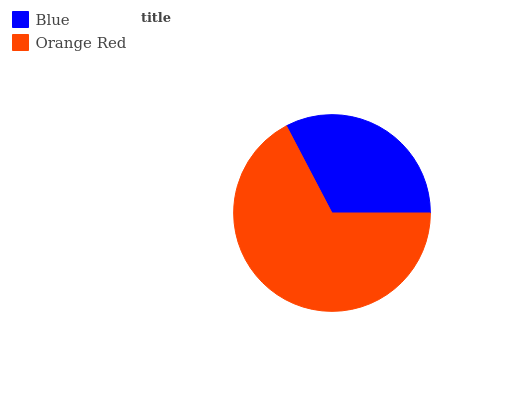Is Blue the minimum?
Answer yes or no. Yes. Is Orange Red the maximum?
Answer yes or no. Yes. Is Orange Red the minimum?
Answer yes or no. No. Is Orange Red greater than Blue?
Answer yes or no. Yes. Is Blue less than Orange Red?
Answer yes or no. Yes. Is Blue greater than Orange Red?
Answer yes or no. No. Is Orange Red less than Blue?
Answer yes or no. No. Is Orange Red the high median?
Answer yes or no. Yes. Is Blue the low median?
Answer yes or no. Yes. Is Blue the high median?
Answer yes or no. No. Is Orange Red the low median?
Answer yes or no. No. 